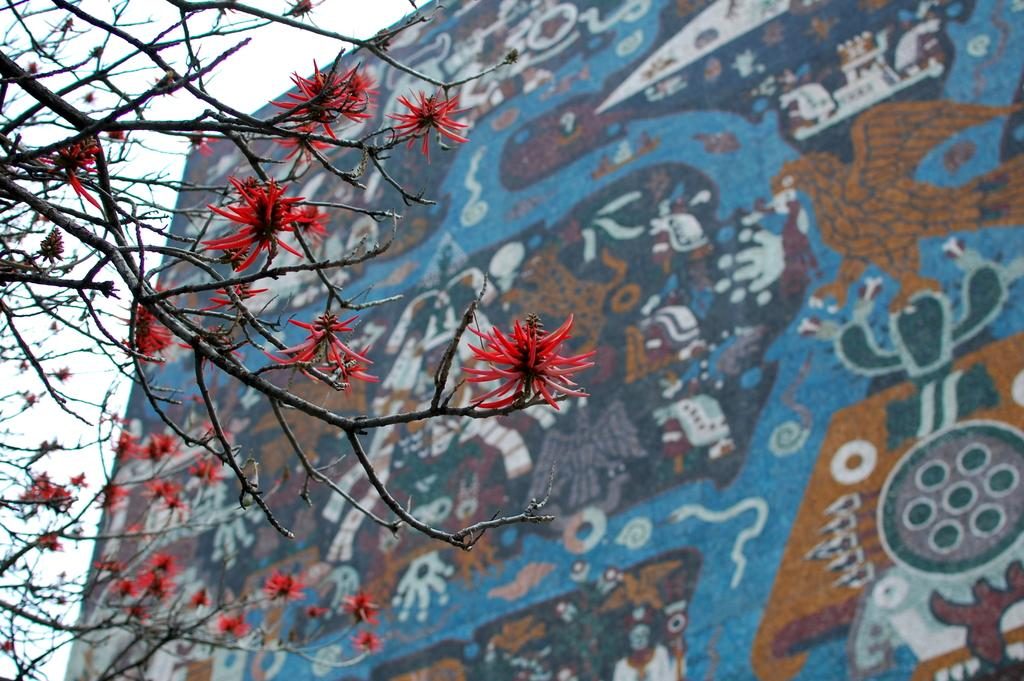What type of vegetation is on the left side of the image? There are branches with red flowers on the left side of the image. What can be seen behind the branches? There is a wall with designs behind the branches. What is visible in the background of the image? The sky is visible in the background of the image. What type of veil is draped over the branches in the image? There is no veil present in the image; it features branches with red flowers and a wall with designs. How many steps can be seen leading up to the branches in the image? There are no steps visible in the image; it only shows branches, a wall, and the sky. 